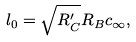Convert formula to latex. <formula><loc_0><loc_0><loc_500><loc_500>l _ { 0 } = \sqrt { R ^ { \prime } _ { C } } R _ { B } c _ { \infty } ,</formula> 